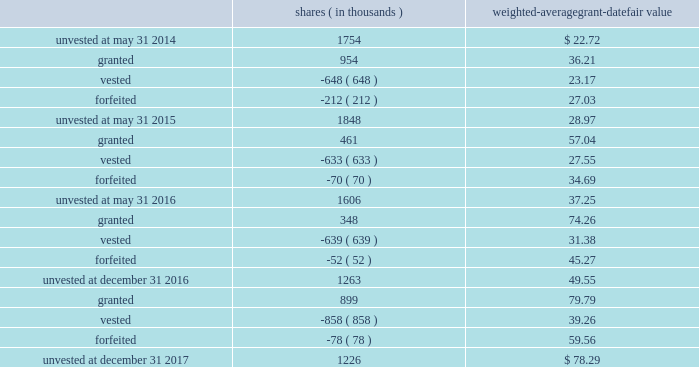Leveraged performance units during the year ended may 31 , 2015 , certain executives were granted performance units that we refer to as 201cleveraged performance units , 201d or 201clpus . 201d lpus contain a market condition based on our relative stock price growth over a three-year performance period .
The lpus contain a minimum threshold performance which , if not met , would result in no payout .
The lpus also contain a maximum award opportunity set as a fixed dollar and fixed number of shares .
After the three-year performance period , which concluded in october 2017 , one-third of the earned units converted to unrestricted common stock .
The remaining two-thirds converted to restricted stock that will vest in equal installments on each of the first two anniversaries of the conversion date .
We recognize share-based compensation expense based on the grant date fair value of the lpus , as determined by use of a monte carlo model , on a straight-line basis over the requisite service period for each separately vesting portion of the lpu award .
The table summarizes the changes in unvested restricted stock and performance awards for the year ended december 31 , 2017 , the 2016 fiscal transition period and for the years ended may 31 , 2016 and 2015 : shares weighted-average grant-date fair value ( in thousands ) .
The total fair value of restricted stock and performance awards vested was $ 33.7 million for the year ended december 31 , 2017 , $ 20.0 million for the 2016 fiscal transition period and $ 17.4 million and $ 15.0 million , respectively , for the years ended may 31 , 2016 and 2015 .
For restricted stock and performance awards , we recognized compensation expense of $ 35.2 million for the year ended december 31 , 2017 , $ 17.2 million for the 2016 fiscal transition period and $ 28.8 million and $ 19.8 million , respectively , for the years ended may 31 , 2016 and 2015 .
As of december 31 , 2017 , there was $ 46.1 million of unrecognized compensation expense related to unvested restricted stock and performance awards that we expect to recognize over a weighted-average period of 1.8 years .
Our restricted stock and performance award plans provide for accelerated vesting under certain conditions .
Stock options stock options are granted with an exercise price equal to 100% ( 100 % ) of fair market value of our common stock on the date of grant and have a term of ten years .
Stock options granted before the year ended may 31 , 2015 vest in equal installments on each of the first four anniversaries of the grant date .
Stock options granted during the year ended may 31 , 2015 and thereafter vest in equal installments on each of the first three anniversaries of the grant date .
Our stock option plans provide for accelerated vesting under certain conditions .
Global payments inc .
| 2017 form 10-k annual report 2013 91 .
What was the percentage chaning in the total fair value of restricted stock and performance awards vested from 2016 to 2017? 
Computations: ((33.7 - 20.0) / 20.0)
Answer: 0.685. 